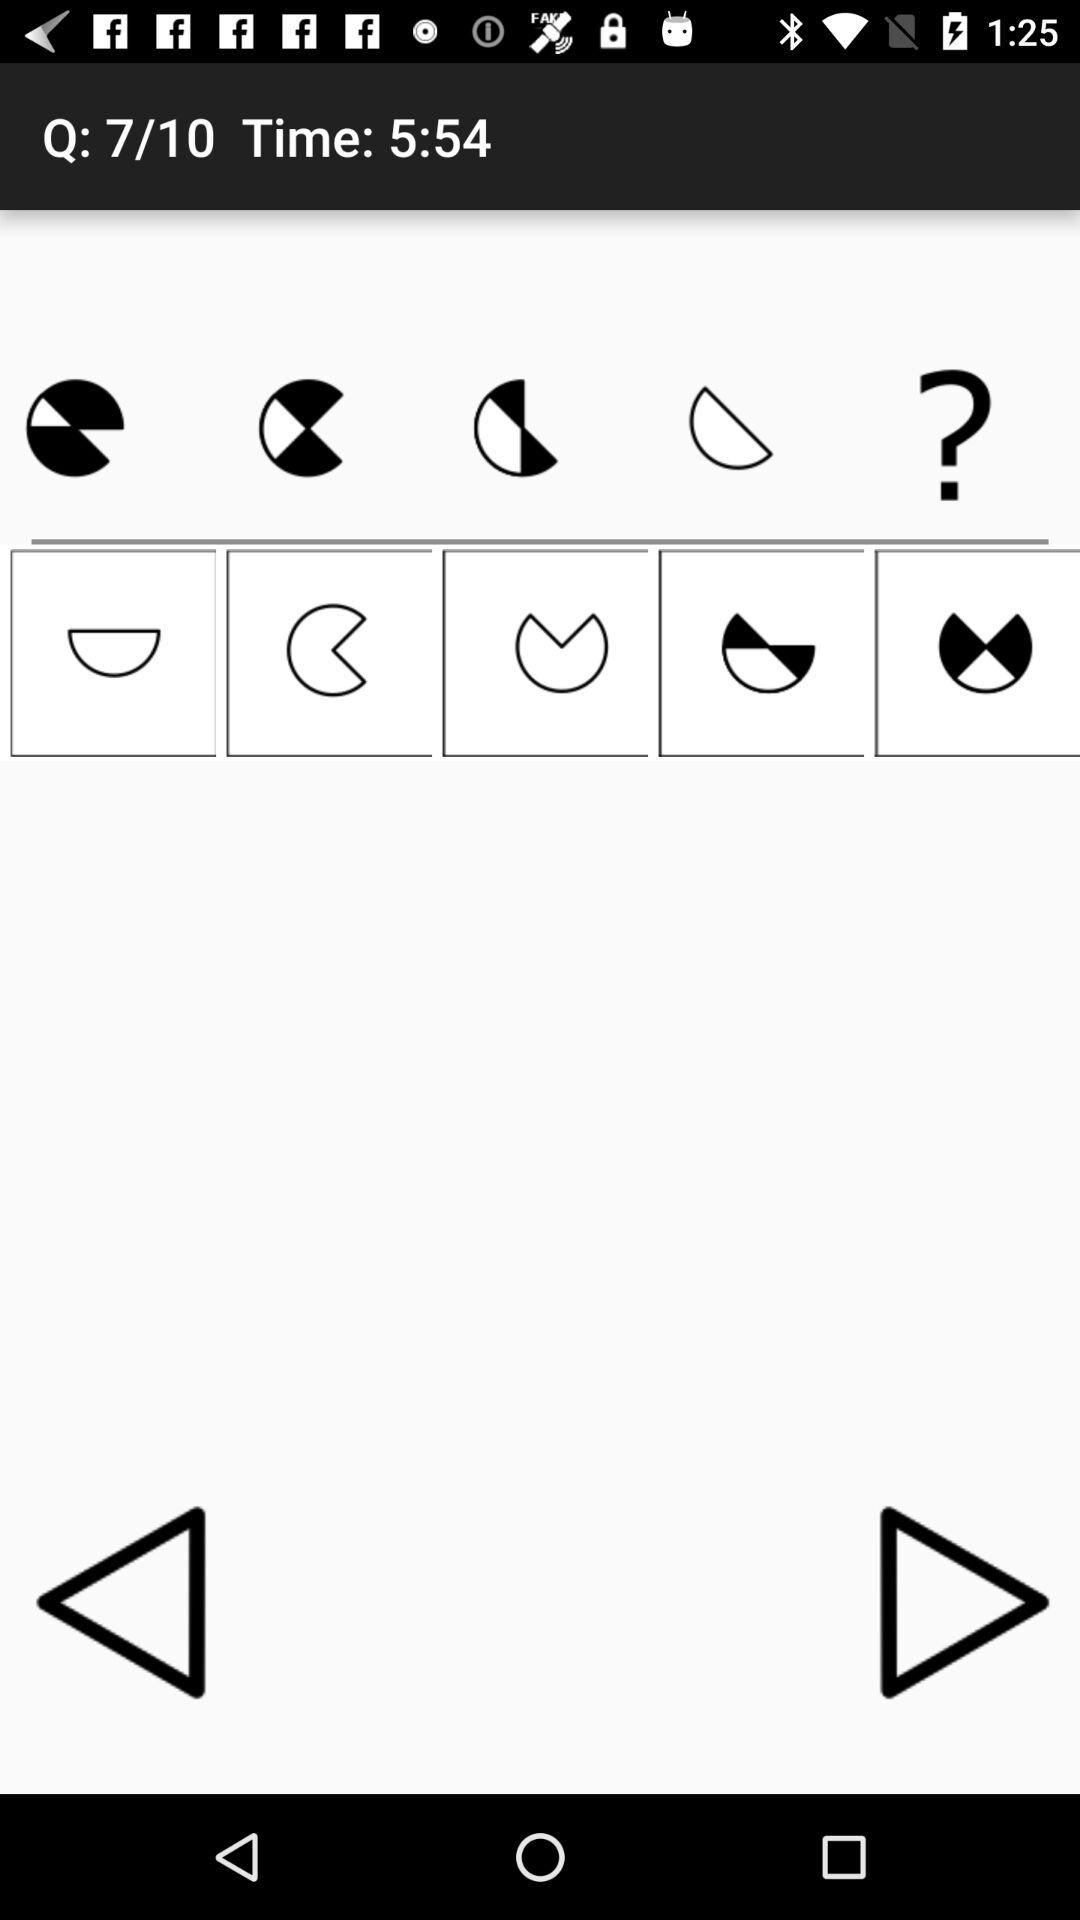Which question am I on? You are on the seventh question. 